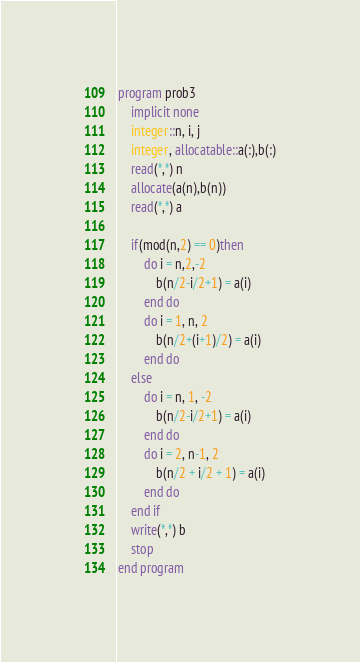<code> <loc_0><loc_0><loc_500><loc_500><_FORTRAN_>program prob3
    implicit none
    integer::n, i, j
    integer, allocatable::a(:),b(:)
    read(*,*) n
    allocate(a(n),b(n))
    read(*,*) a

    if(mod(n,2) == 0)then
        do i = n,2,-2
            b(n/2-i/2+1) = a(i)
        end do
        do i = 1, n, 2
            b(n/2+(i+1)/2) = a(i)
        end do
    else
        do i = n, 1, -2
            b(n/2-i/2+1) = a(i)
        end do
        do i = 2, n-1, 2
            b(n/2 + i/2 + 1) = a(i)
        end do
    end if
    write(*,*) b
    stop
end program</code> 